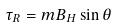Convert formula to latex. <formula><loc_0><loc_0><loc_500><loc_500>\tau _ { R } = m B _ { H } \sin \theta</formula> 